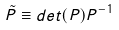<formula> <loc_0><loc_0><loc_500><loc_500>\tilde { P } \equiv d e t ( P ) P ^ { - 1 }</formula> 